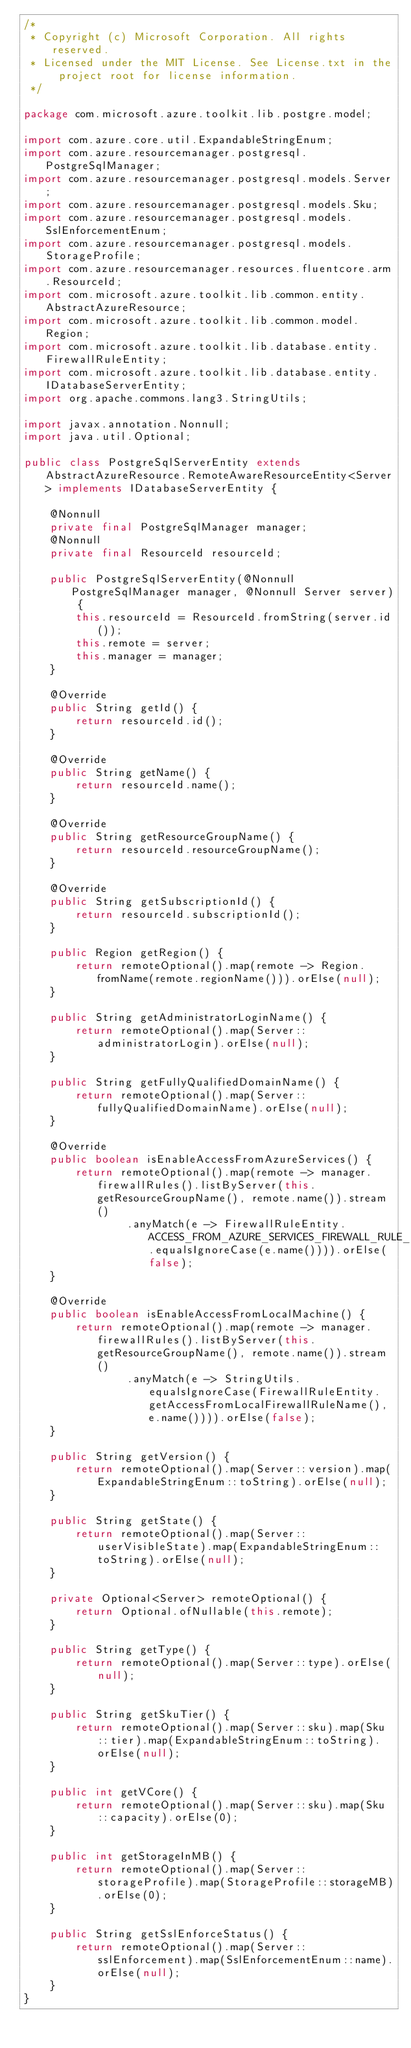<code> <loc_0><loc_0><loc_500><loc_500><_Java_>/*
 * Copyright (c) Microsoft Corporation. All rights reserved.
 * Licensed under the MIT License. See License.txt in the project root for license information.
 */

package com.microsoft.azure.toolkit.lib.postgre.model;

import com.azure.core.util.ExpandableStringEnum;
import com.azure.resourcemanager.postgresql.PostgreSqlManager;
import com.azure.resourcemanager.postgresql.models.Server;
import com.azure.resourcemanager.postgresql.models.Sku;
import com.azure.resourcemanager.postgresql.models.SslEnforcementEnum;
import com.azure.resourcemanager.postgresql.models.StorageProfile;
import com.azure.resourcemanager.resources.fluentcore.arm.ResourceId;
import com.microsoft.azure.toolkit.lib.common.entity.AbstractAzureResource;
import com.microsoft.azure.toolkit.lib.common.model.Region;
import com.microsoft.azure.toolkit.lib.database.entity.FirewallRuleEntity;
import com.microsoft.azure.toolkit.lib.database.entity.IDatabaseServerEntity;
import org.apache.commons.lang3.StringUtils;

import javax.annotation.Nonnull;
import java.util.Optional;

public class PostgreSqlServerEntity extends AbstractAzureResource.RemoteAwareResourceEntity<Server> implements IDatabaseServerEntity {

    @Nonnull
    private final PostgreSqlManager manager;
    @Nonnull
    private final ResourceId resourceId;

    public PostgreSqlServerEntity(@Nonnull PostgreSqlManager manager, @Nonnull Server server) {
        this.resourceId = ResourceId.fromString(server.id());
        this.remote = server;
        this.manager = manager;
    }

    @Override
    public String getId() {
        return resourceId.id();
    }

    @Override
    public String getName() {
        return resourceId.name();
    }

    @Override
    public String getResourceGroupName() {
        return resourceId.resourceGroupName();
    }

    @Override
    public String getSubscriptionId() {
        return resourceId.subscriptionId();
    }

    public Region getRegion() {
        return remoteOptional().map(remote -> Region.fromName(remote.regionName())).orElse(null);
    }

    public String getAdministratorLoginName() {
        return remoteOptional().map(Server::administratorLogin).orElse(null);
    }

    public String getFullyQualifiedDomainName() {
        return remoteOptional().map(Server::fullyQualifiedDomainName).orElse(null);
    }

    @Override
    public boolean isEnableAccessFromAzureServices() {
        return remoteOptional().map(remote -> manager.firewallRules().listByServer(this.getResourceGroupName(), remote.name()).stream()
                .anyMatch(e -> FirewallRuleEntity.ACCESS_FROM_AZURE_SERVICES_FIREWALL_RULE_NAME.equalsIgnoreCase(e.name()))).orElse(false);
    }

    @Override
    public boolean isEnableAccessFromLocalMachine() {
        return remoteOptional().map(remote -> manager.firewallRules().listByServer(this.getResourceGroupName(), remote.name()).stream()
                .anyMatch(e -> StringUtils.equalsIgnoreCase(FirewallRuleEntity.getAccessFromLocalFirewallRuleName(), e.name()))).orElse(false);
    }

    public String getVersion() {
        return remoteOptional().map(Server::version).map(ExpandableStringEnum::toString).orElse(null);
    }

    public String getState() {
        return remoteOptional().map(Server::userVisibleState).map(ExpandableStringEnum::toString).orElse(null);
    }

    private Optional<Server> remoteOptional() {
        return Optional.ofNullable(this.remote);
    }

    public String getType() {
        return remoteOptional().map(Server::type).orElse(null);
    }

    public String getSkuTier() {
        return remoteOptional().map(Server::sku).map(Sku::tier).map(ExpandableStringEnum::toString).orElse(null);
    }

    public int getVCore() {
        return remoteOptional().map(Server::sku).map(Sku::capacity).orElse(0);
    }

    public int getStorageInMB() {
        return remoteOptional().map(Server::storageProfile).map(StorageProfile::storageMB).orElse(0);
    }

    public String getSslEnforceStatus() {
        return remoteOptional().map(Server::sslEnforcement).map(SslEnforcementEnum::name).orElse(null);
    }
}
</code> 